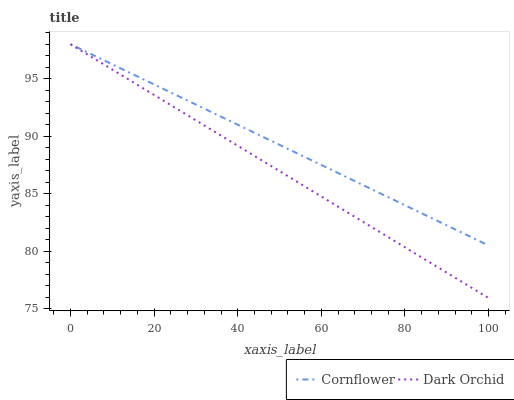Does Dark Orchid have the minimum area under the curve?
Answer yes or no. Yes. Does Cornflower have the maximum area under the curve?
Answer yes or no. Yes. Does Dark Orchid have the maximum area under the curve?
Answer yes or no. No. Is Cornflower the smoothest?
Answer yes or no. Yes. Is Dark Orchid the roughest?
Answer yes or no. Yes. Is Dark Orchid the smoothest?
Answer yes or no. No. Does Dark Orchid have the lowest value?
Answer yes or no. Yes. Does Dark Orchid have the highest value?
Answer yes or no. Yes. Does Dark Orchid intersect Cornflower?
Answer yes or no. Yes. Is Dark Orchid less than Cornflower?
Answer yes or no. No. Is Dark Orchid greater than Cornflower?
Answer yes or no. No. 